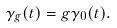<formula> <loc_0><loc_0><loc_500><loc_500>\gamma _ { g } ( t ) = g \gamma _ { 0 } ( t ) .</formula> 